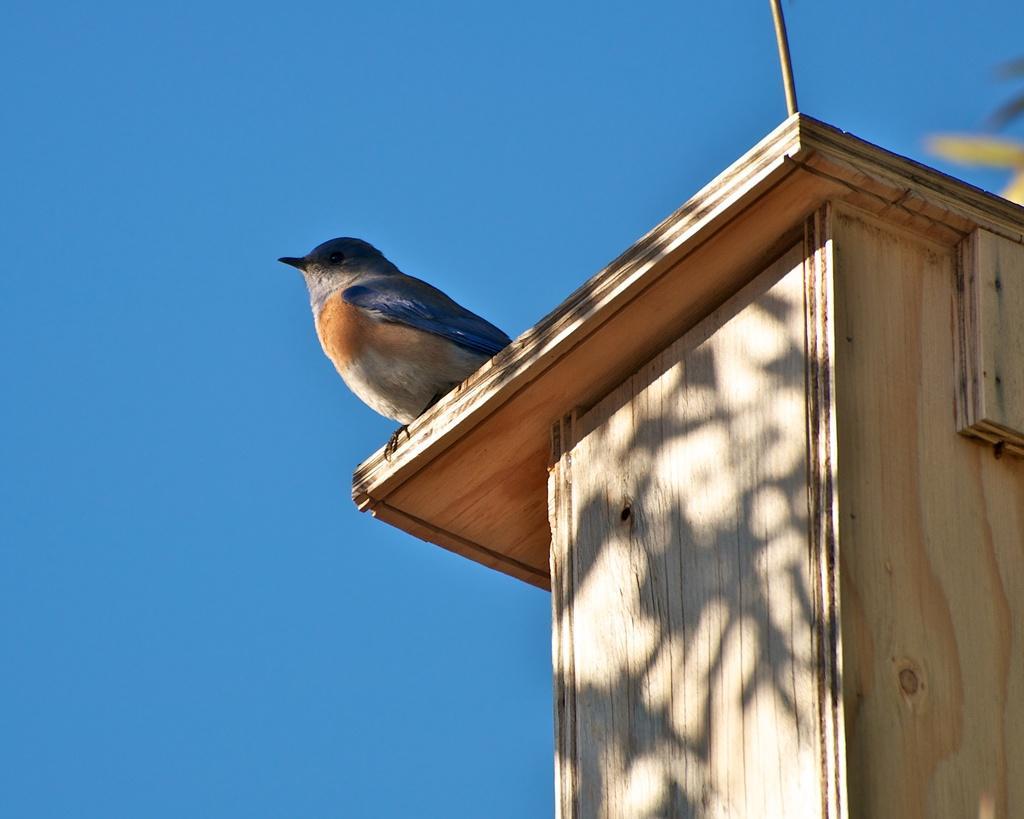Can you describe this image briefly? In the center of the image, we can see a bird on a wooden box and in the background, there is sky. 